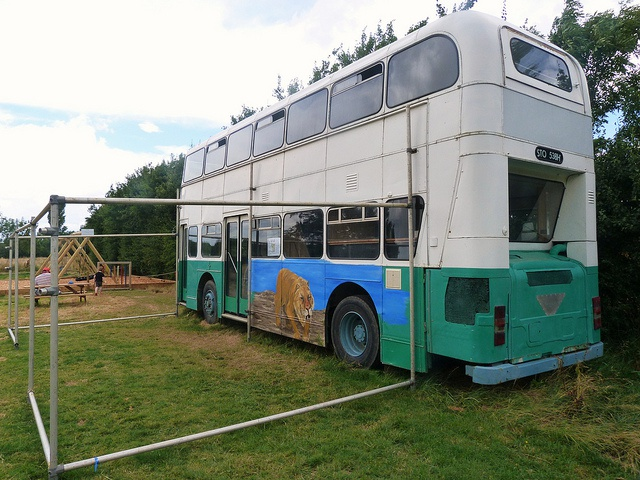Describe the objects in this image and their specific colors. I can see bus in white, darkgray, lightgray, black, and teal tones, people in white, black, gray, and olive tones, people in white, darkgray, gray, and salmon tones, dining table in white, black, gray, brown, and maroon tones, and bench in white, tan, gray, olive, and brown tones in this image. 